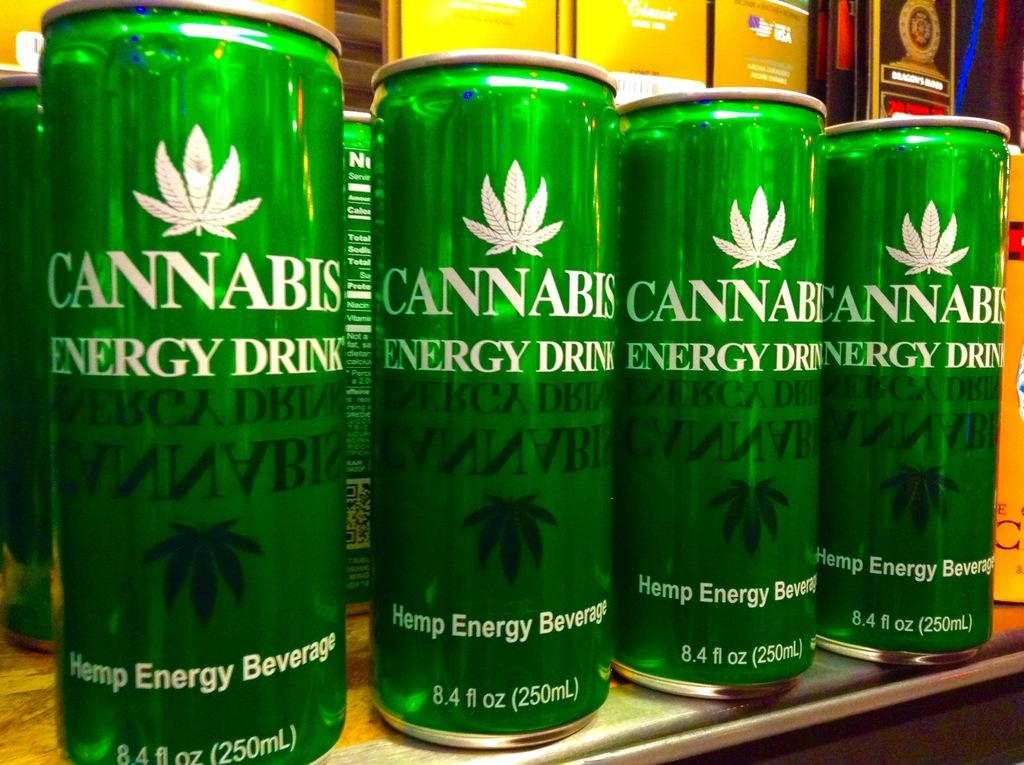<image>
Relay a brief, clear account of the picture shown. Multiple green Cannabis Energy Drinks are arranged on a shelf. 